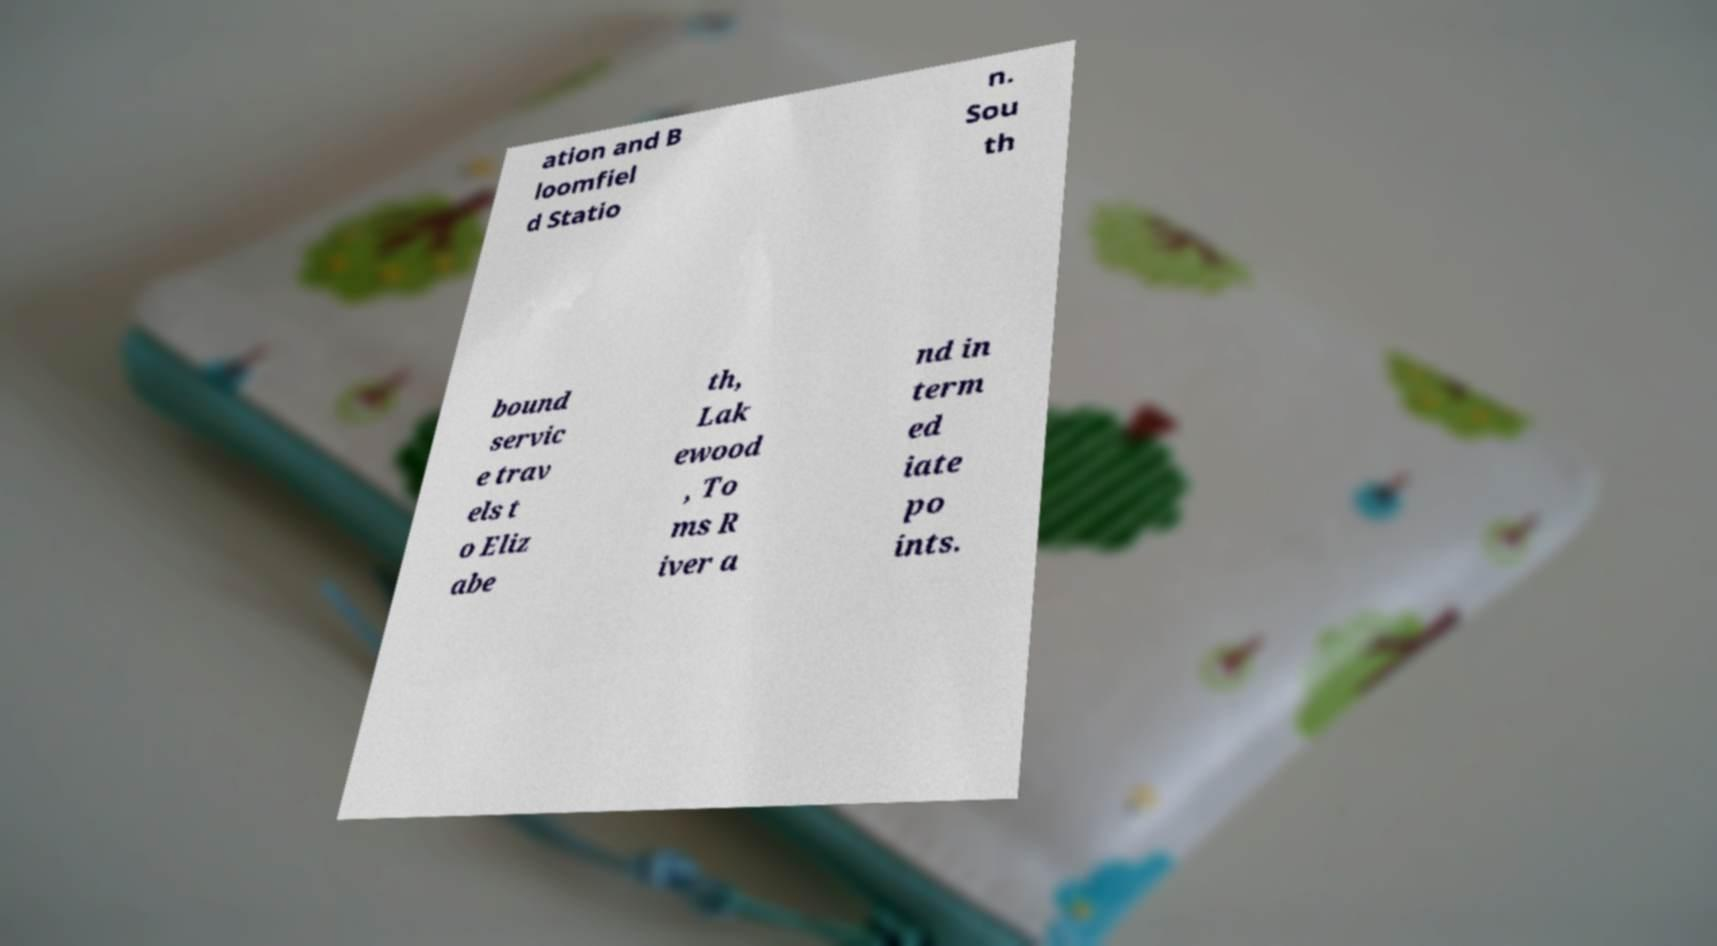Can you read and provide the text displayed in the image?This photo seems to have some interesting text. Can you extract and type it out for me? ation and B loomfiel d Statio n. Sou th bound servic e trav els t o Eliz abe th, Lak ewood , To ms R iver a nd in term ed iate po ints. 